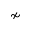<formula> <loc_0><loc_0><loc_500><loc_500>\nsim</formula> 